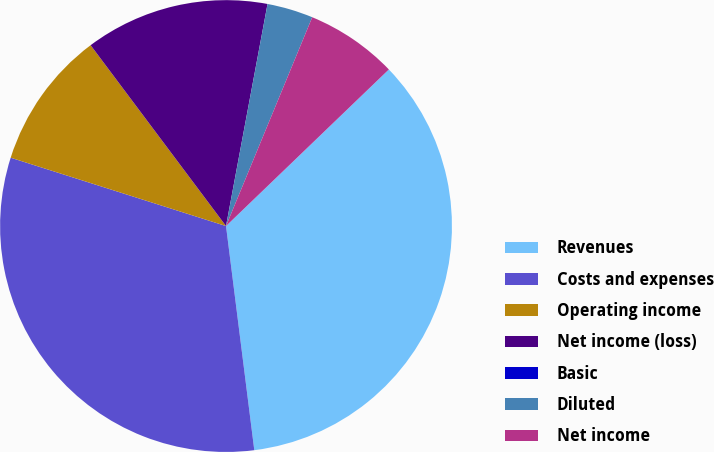Convert chart to OTSL. <chart><loc_0><loc_0><loc_500><loc_500><pie_chart><fcel>Revenues<fcel>Costs and expenses<fcel>Operating income<fcel>Net income (loss)<fcel>Basic<fcel>Diluted<fcel>Net income<nl><fcel>35.19%<fcel>31.89%<fcel>9.88%<fcel>13.17%<fcel>0.0%<fcel>3.29%<fcel>6.58%<nl></chart> 